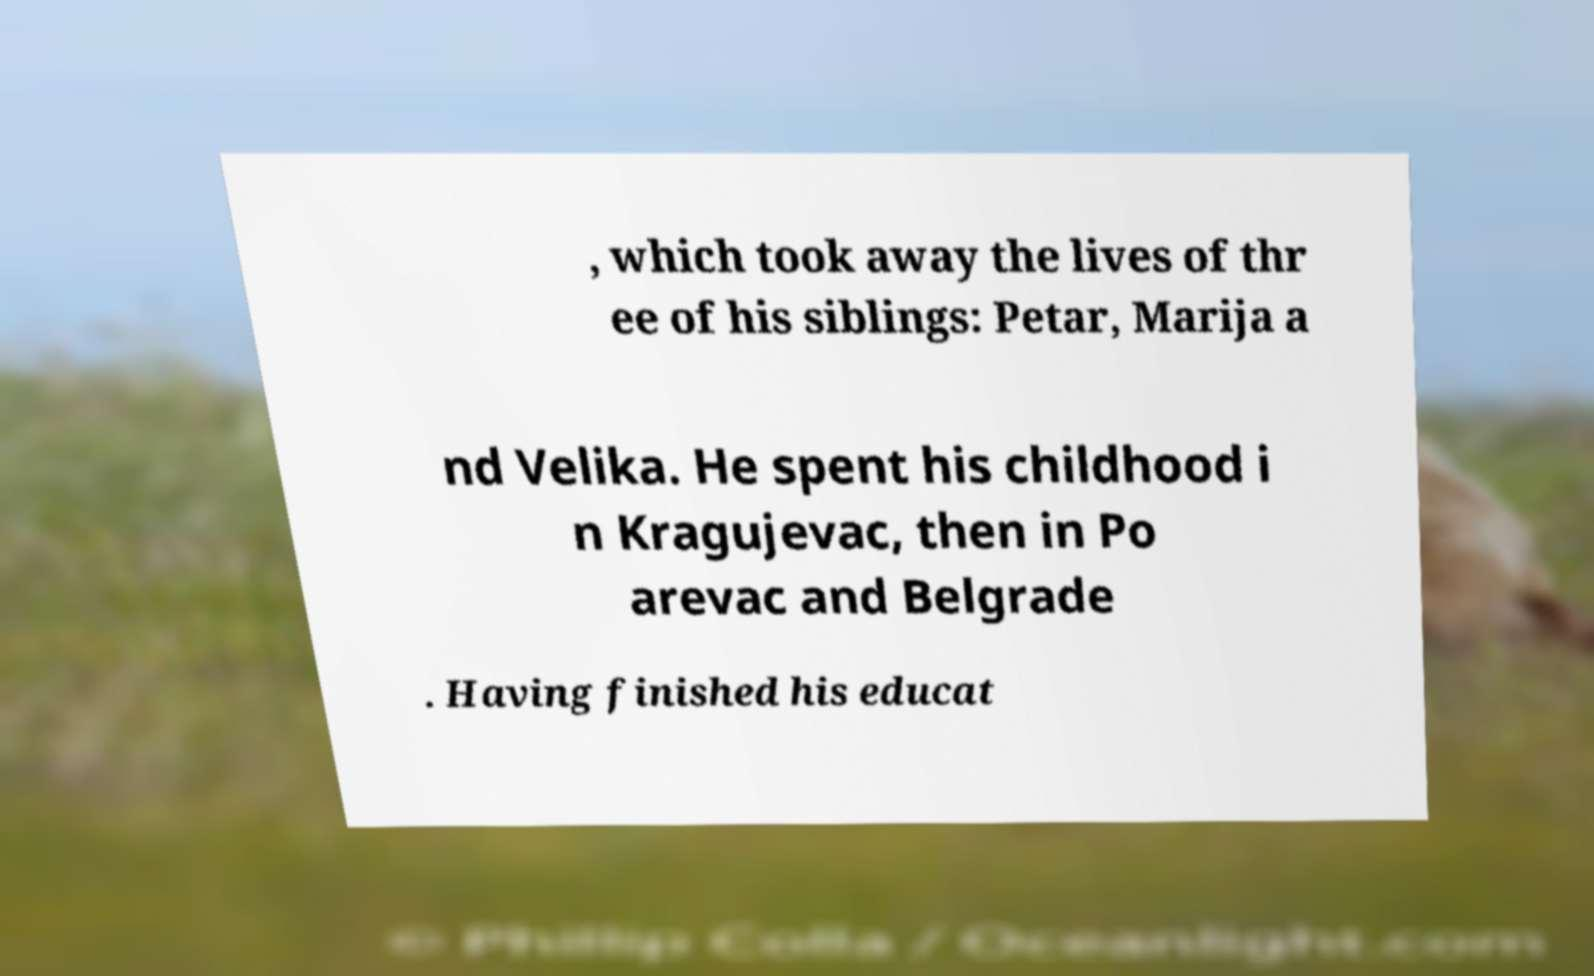Please identify and transcribe the text found in this image. , which took away the lives of thr ee of his siblings: Petar, Marija a nd Velika. He spent his childhood i n Kragujevac, then in Po arevac and Belgrade . Having finished his educat 